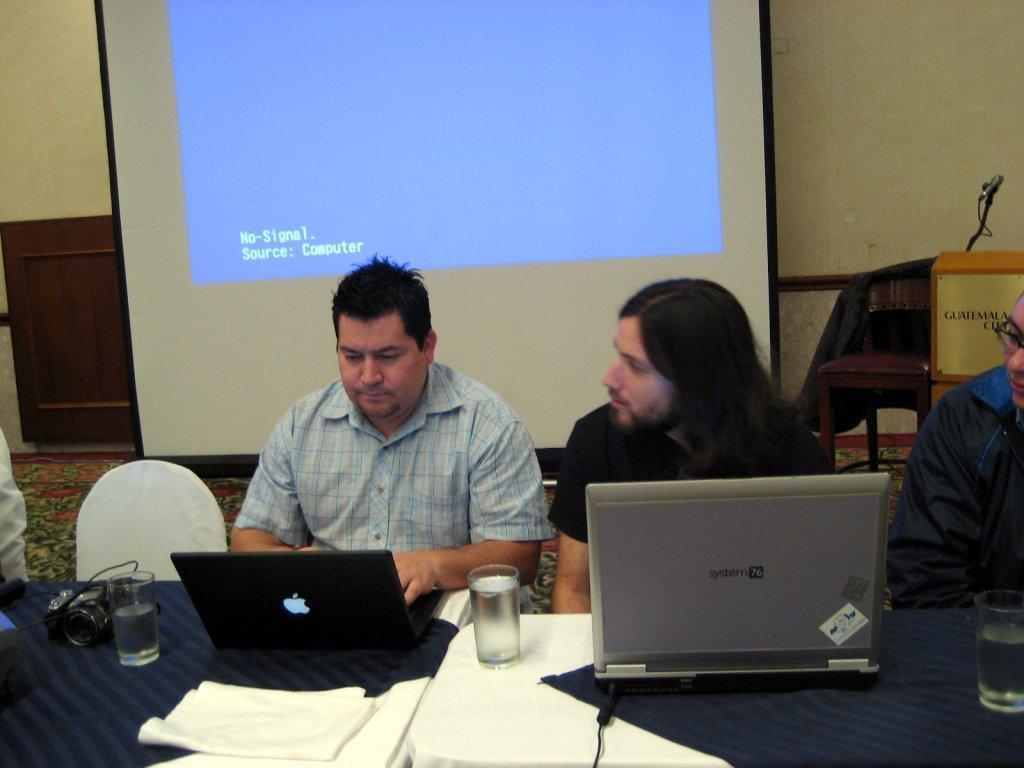Describe this image in one or two sentences. People are sitting on chairs. In-front of them there are tables. Above that tables there are laptops, glasses, camera and things. Floor with carpet. In-front of the wall there is a screen, chair and podium along with mic. Above the chair there is a jacket. One person is working on his laptop. 